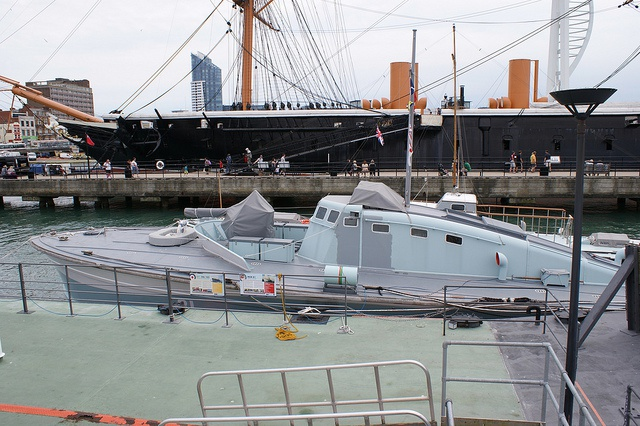Describe the objects in this image and their specific colors. I can see boat in white, darkgray, gray, and black tones, boat in white, darkgray, gray, and black tones, boat in white, black, lightgray, darkgray, and salmon tones, people in white, black, gray, darkgray, and lightgray tones, and bench in white, gray, and black tones in this image. 